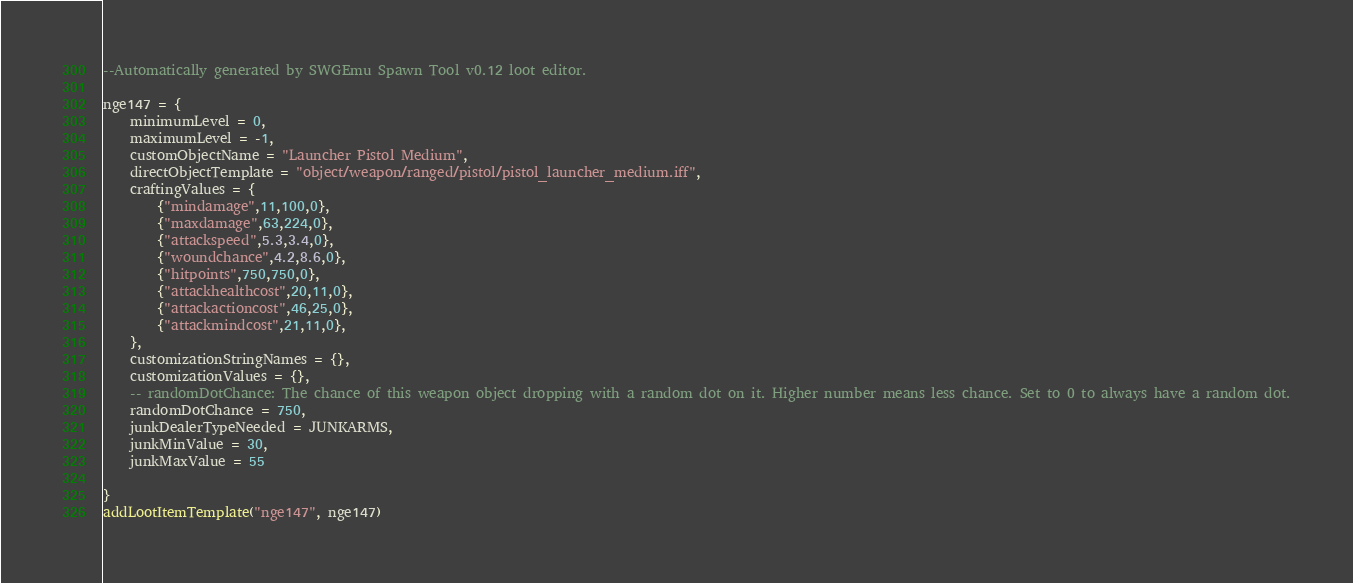Convert code to text. <code><loc_0><loc_0><loc_500><loc_500><_Lua_>--Automatically generated by SWGEmu Spawn Tool v0.12 loot editor. 

nge147 = {
	minimumLevel = 0,
	maximumLevel = -1,
	customObjectName = "Launcher Pistol Medium",
	directObjectTemplate = "object/weapon/ranged/pistol/pistol_launcher_medium.iff",
	craftingValues = {
		{"mindamage",11,100,0},
		{"maxdamage",63,224,0},
		{"attackspeed",5.3,3.4,0},
		{"woundchance",4.2,8.6,0},
		{"hitpoints",750,750,0},
		{"attackhealthcost",20,11,0},
		{"attackactioncost",46,25,0},
		{"attackmindcost",21,11,0},
	},
	customizationStringNames = {},
	customizationValues = {},
	-- randomDotChance: The chance of this weapon object dropping with a random dot on it. Higher number means less chance. Set to 0 to always have a random dot.
	randomDotChance = 750,
	junkDealerTypeNeeded = JUNKARMS,
	junkMinValue = 30,
	junkMaxValue = 55

}
addLootItemTemplate("nge147", nge147)
</code> 